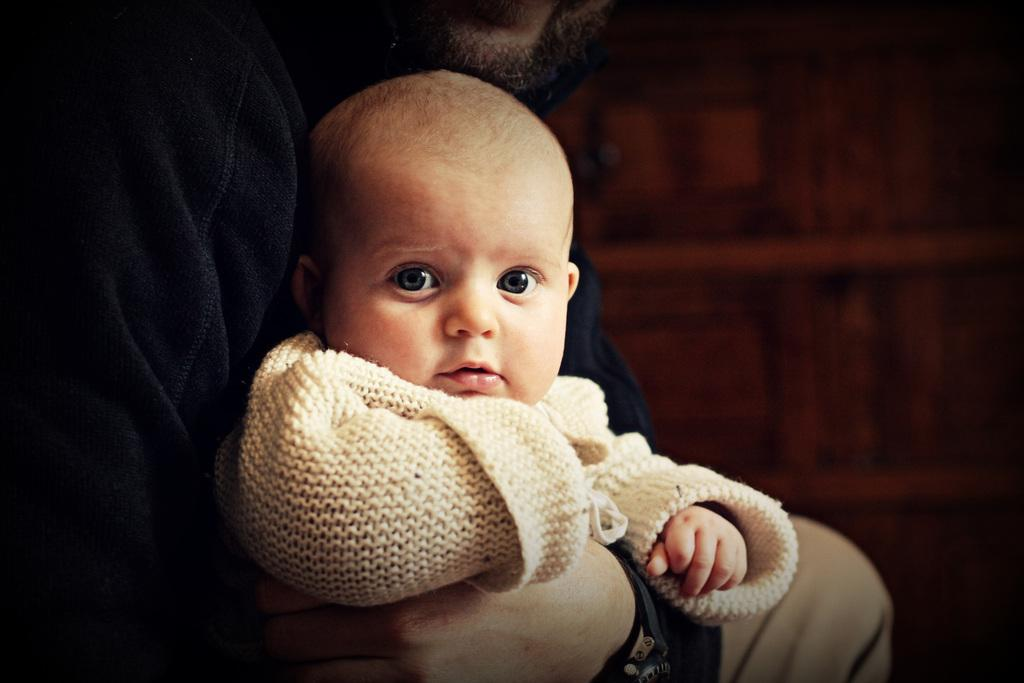What is the main subject of the image? The main subject of the image is a kid. Can you describe the kid's attire? The kid is wearing a white dress. Who else is present in the image? There is a person in the image. What is the person wearing? The person is wearing a black dress. What is the person doing with the kid? The person is holding the kid. Is there a bike visible in the image? No, there is no bike present in the image. Can you see any salt being used in the image? No, there is no salt visible in the image. 